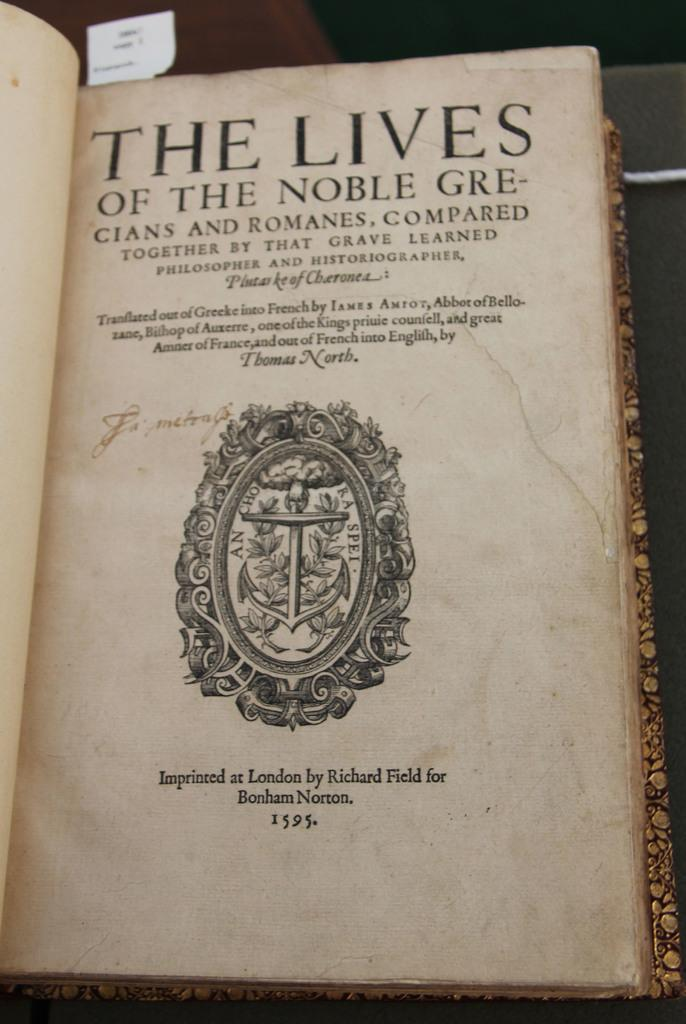Provide a one-sentence caption for the provided image. The title page of The Lives of the Noble Grecians and Romanes shows a fancy crest with an anchor on it. 